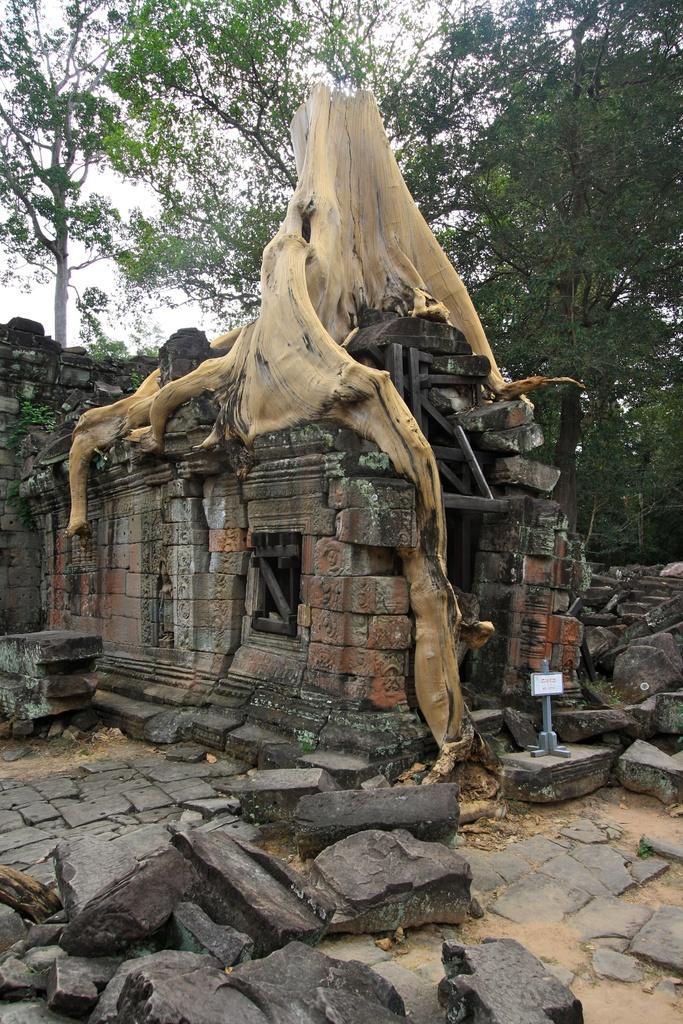Please provide a concise description of this image. In this image, we can see some trees. There is a temple and stem in the middle of the image. There are rocks at the bottom of the image. 